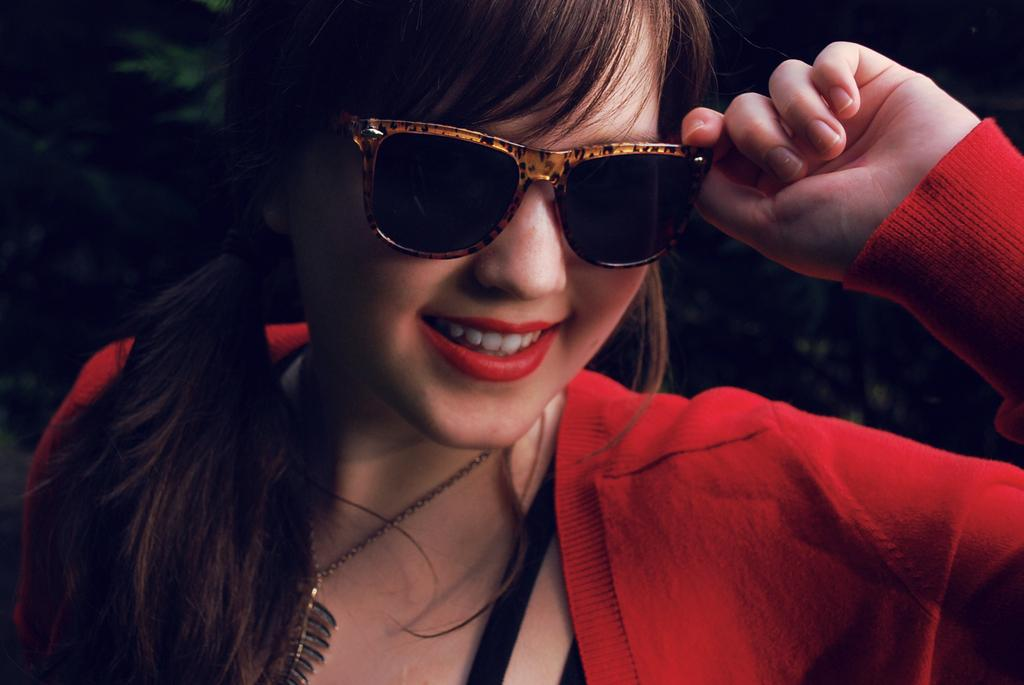Who is the main subject in the image? There is a woman in the image. What is the woman wearing on her face? The woman is wearing goggles. What color is the dress the woman is wearing? The woman is wearing a red dress. What can be observed about the background of the image? The background of the image is dark. What type of throat lozenges can be seen on the shelf behind the woman in the image? There is no shelf or throat lozenges present in the image. 